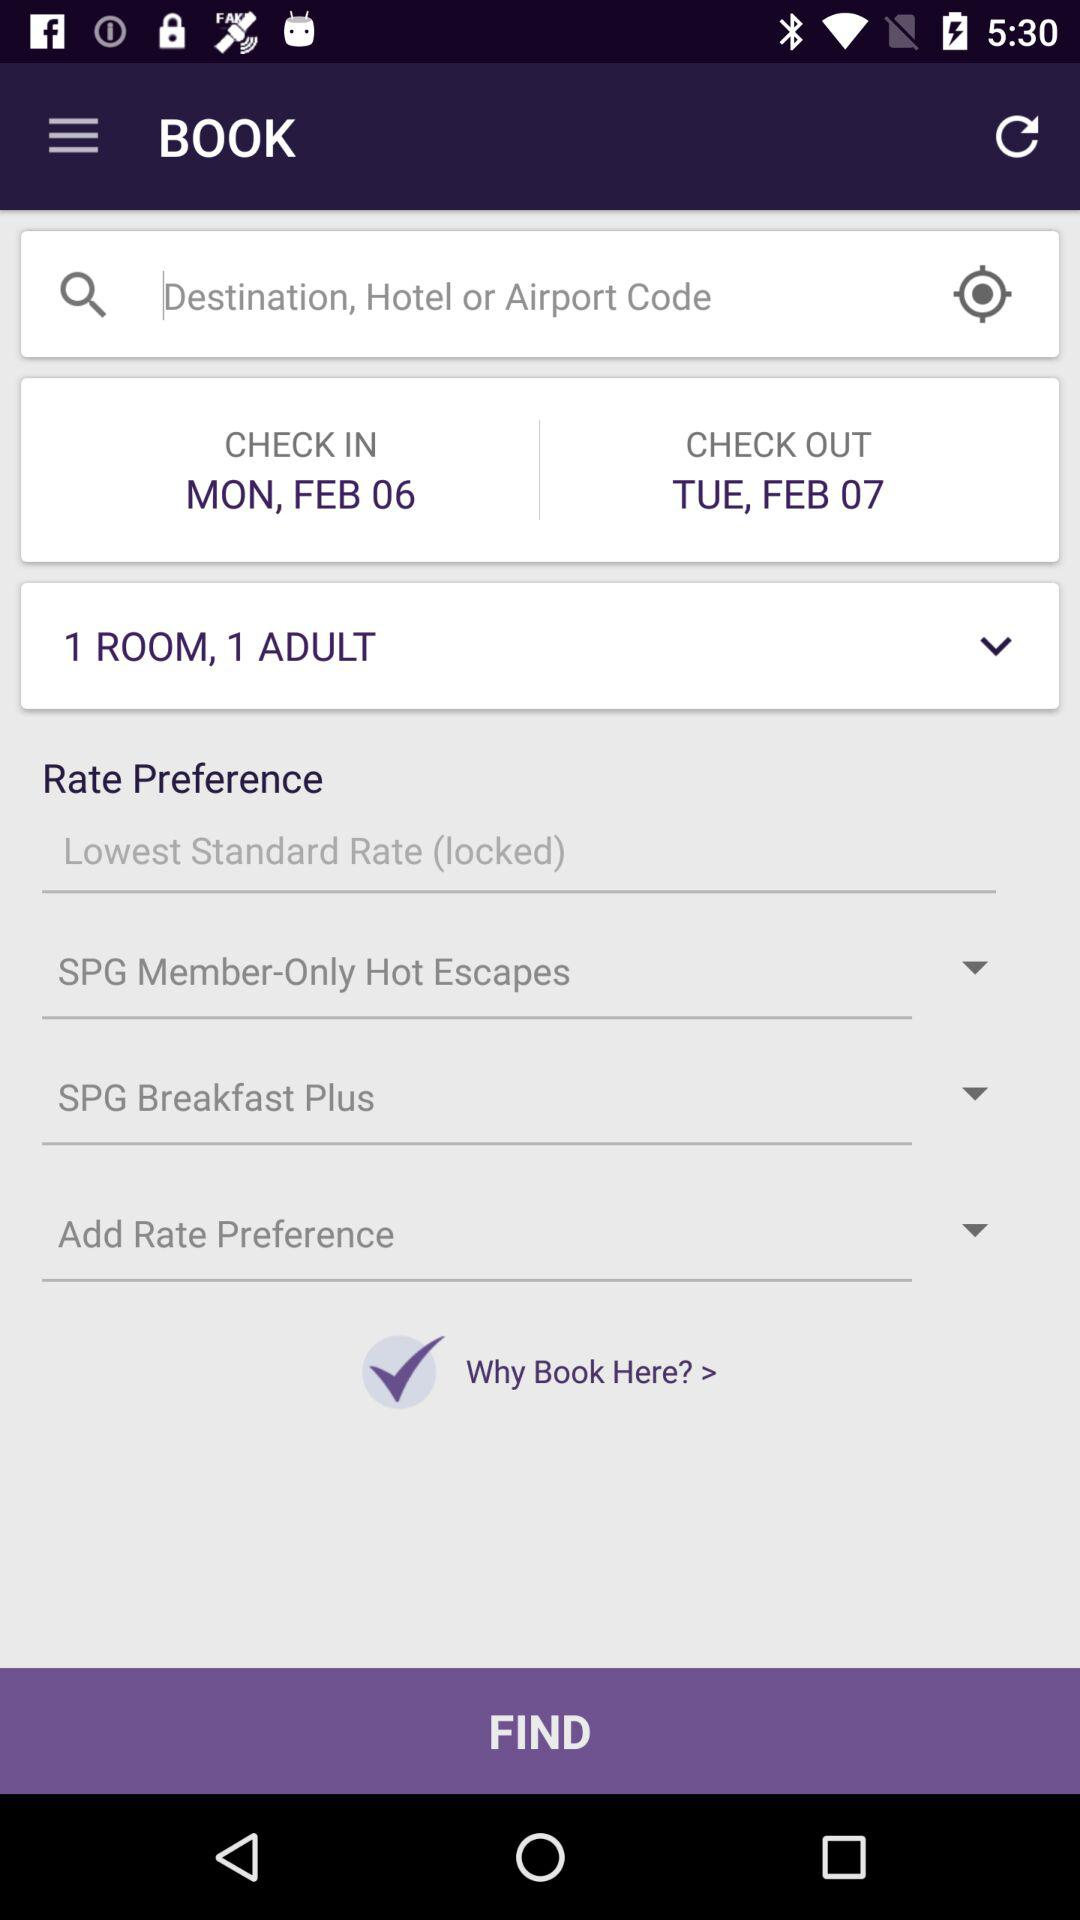What is the check-in date? The check-in date is Monday, February 6. 